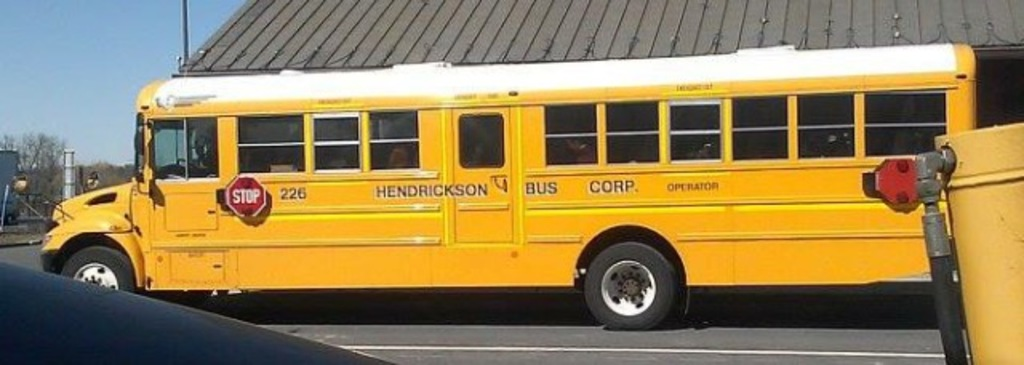Provide a one-sentence caption for the provided image. A vibrant yellow school bus, marked with '226' and labeled as belonging to Henderson Bus Corp, is parked under a clear blue sky, possibly waiting to transport students safely. 